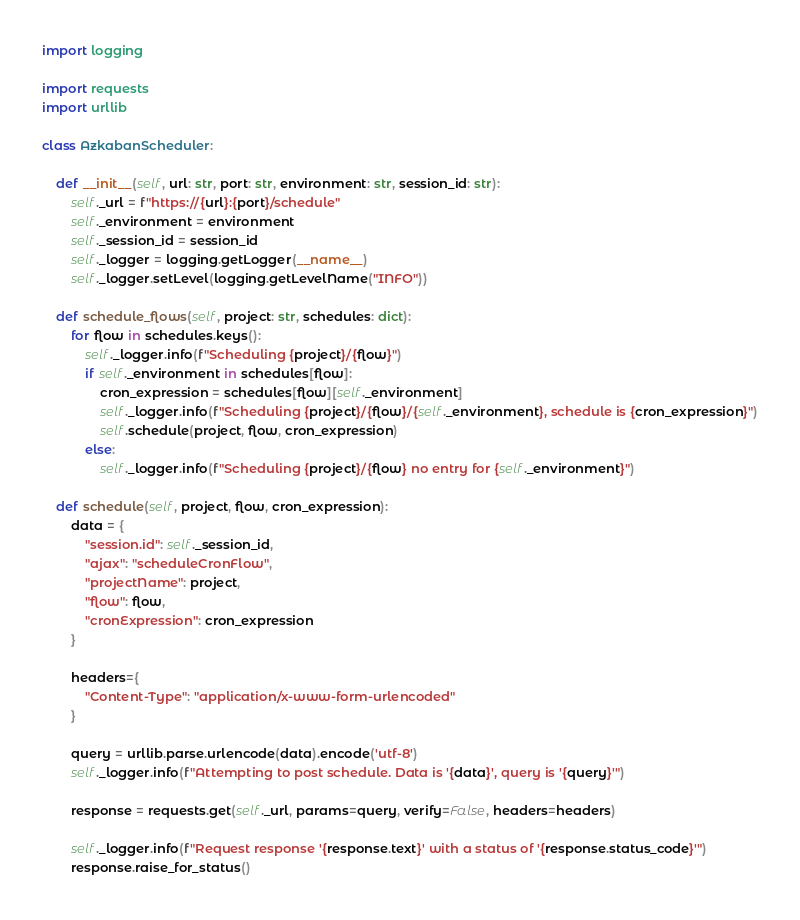Convert code to text. <code><loc_0><loc_0><loc_500><loc_500><_Python_>import logging

import requests
import urllib

class AzkabanScheduler:

    def __init__(self, url: str, port: str, environment: str, session_id: str):
        self._url = f"https://{url}:{port}/schedule"
        self._environment = environment
        self._session_id = session_id
        self._logger = logging.getLogger(__name__)
        self._logger.setLevel(logging.getLevelName("INFO"))

    def schedule_flows(self, project: str, schedules: dict):
        for flow in schedules.keys():
            self._logger.info(f"Scheduling {project}/{flow}")
            if self._environment in schedules[flow]:
                cron_expression = schedules[flow][self._environment]
                self._logger.info(f"Scheduling {project}/{flow}/{self._environment}, schedule is {cron_expression}")
                self.schedule(project, flow, cron_expression)
            else:
                self._logger.info(f"Scheduling {project}/{flow} no entry for {self._environment}")

    def schedule(self, project, flow, cron_expression):
        data = {
            "session.id": self._session_id,
            "ajax": "scheduleCronFlow",
            "projectName": project,
            "flow": flow,
            "cronExpression": cron_expression
        }

        headers={
            "Content-Type": "application/x-www-form-urlencoded"
        }

        query = urllib.parse.urlencode(data).encode('utf-8')
        self._logger.info(f"Attempting to post schedule. Data is '{data}', query is '{query}'")

        response = requests.get(self._url, params=query, verify=False, headers=headers)

        self._logger.info(f"Request response '{response.text}' with a status of '{response.status_code}'")
        response.raise_for_status()

</code> 